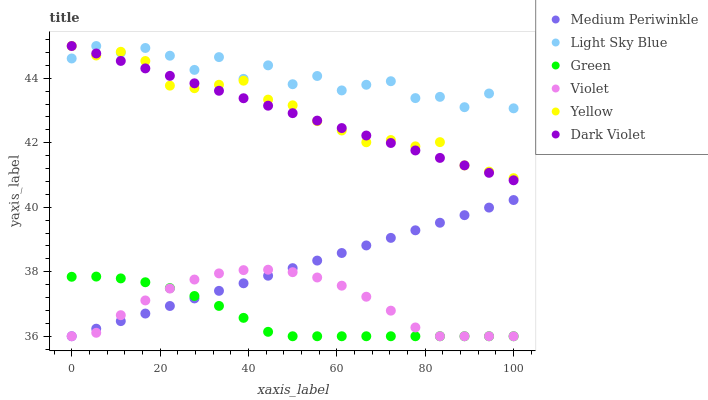Does Green have the minimum area under the curve?
Answer yes or no. Yes. Does Light Sky Blue have the maximum area under the curve?
Answer yes or no. Yes. Does Dark Violet have the minimum area under the curve?
Answer yes or no. No. Does Dark Violet have the maximum area under the curve?
Answer yes or no. No. Is Medium Periwinkle the smoothest?
Answer yes or no. Yes. Is Light Sky Blue the roughest?
Answer yes or no. Yes. Is Dark Violet the smoothest?
Answer yes or no. No. Is Dark Violet the roughest?
Answer yes or no. No. Does Medium Periwinkle have the lowest value?
Answer yes or no. Yes. Does Dark Violet have the lowest value?
Answer yes or no. No. Does Yellow have the highest value?
Answer yes or no. Yes. Does Green have the highest value?
Answer yes or no. No. Is Medium Periwinkle less than Light Sky Blue?
Answer yes or no. Yes. Is Yellow greater than Medium Periwinkle?
Answer yes or no. Yes. Does Light Sky Blue intersect Dark Violet?
Answer yes or no. Yes. Is Light Sky Blue less than Dark Violet?
Answer yes or no. No. Is Light Sky Blue greater than Dark Violet?
Answer yes or no. No. Does Medium Periwinkle intersect Light Sky Blue?
Answer yes or no. No. 